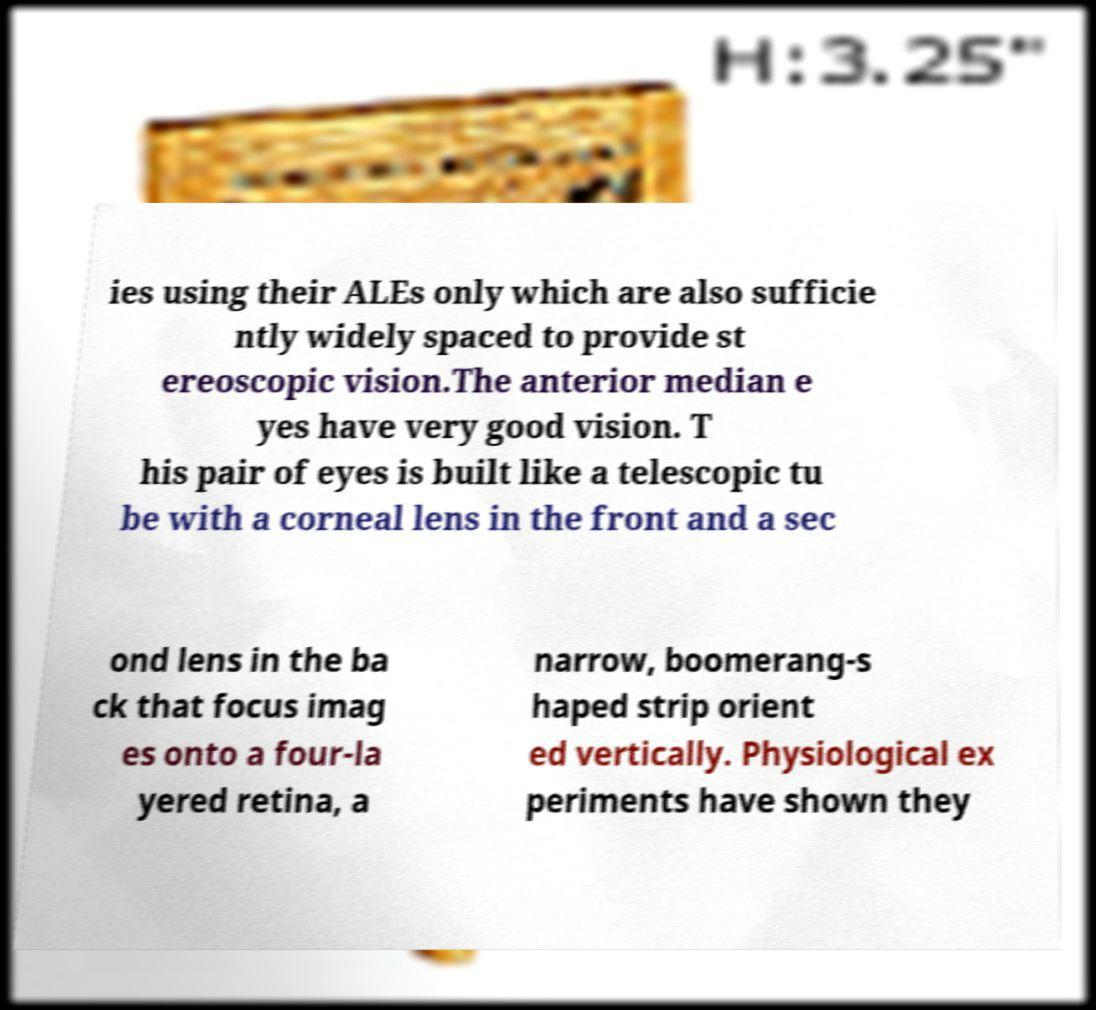Could you extract and type out the text from this image? ies using their ALEs only which are also sufficie ntly widely spaced to provide st ereoscopic vision.The anterior median e yes have very good vision. T his pair of eyes is built like a telescopic tu be with a corneal lens in the front and a sec ond lens in the ba ck that focus imag es onto a four-la yered retina, a narrow, boomerang-s haped strip orient ed vertically. Physiological ex periments have shown they 